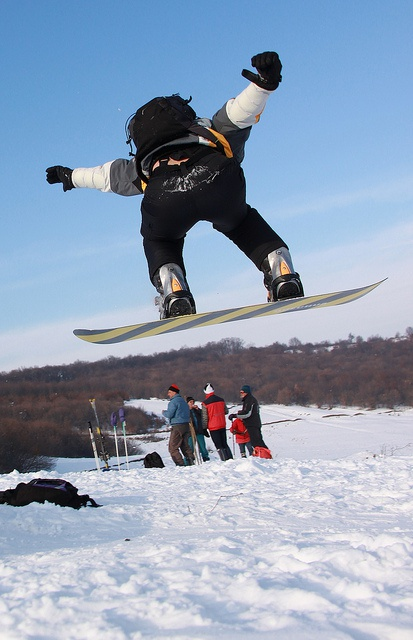Describe the objects in this image and their specific colors. I can see people in gray, black, lightblue, and lightgray tones, snowboard in gray, darkgray, and tan tones, backpack in gray, black, and maroon tones, people in gray, black, and blue tones, and people in gray, black, and brown tones in this image. 